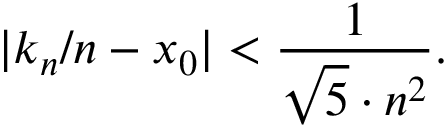Convert formula to latex. <formula><loc_0><loc_0><loc_500><loc_500>| k _ { n } / n - x _ { 0 } | < { \frac { 1 } { { \sqrt { 5 } } \cdot n ^ { 2 } } } .</formula> 